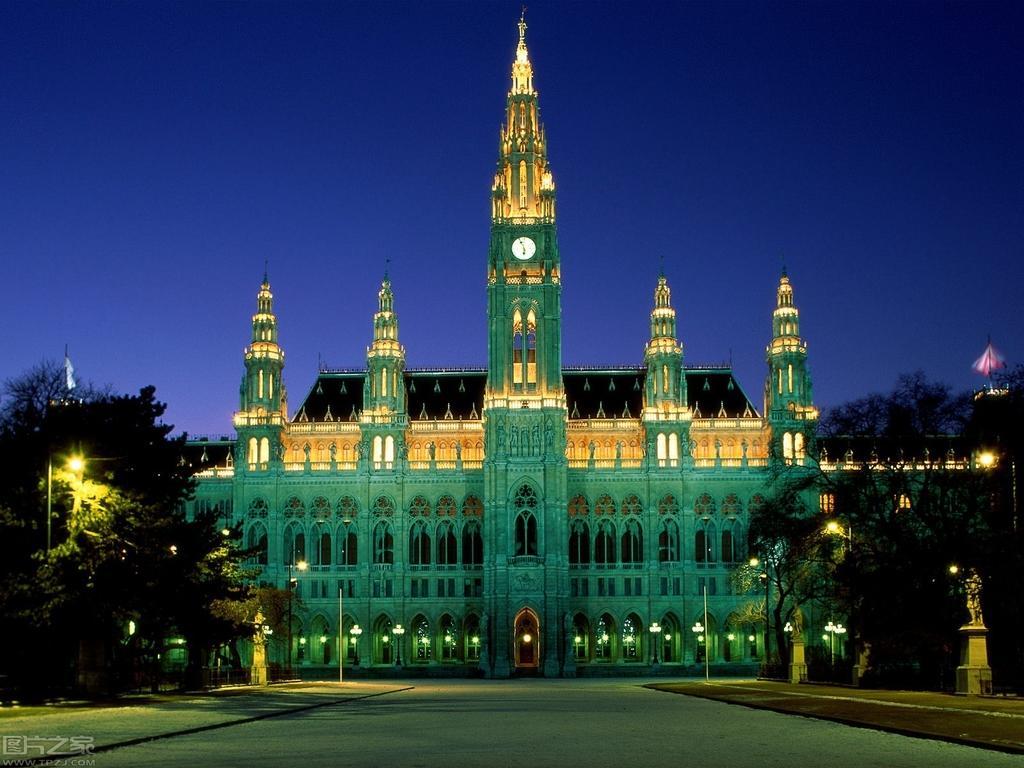Describe this image in one or two sentences. In the center of the image, we can see building and in the background, there are trees, lights, pillars. At the bottom, there is road. 